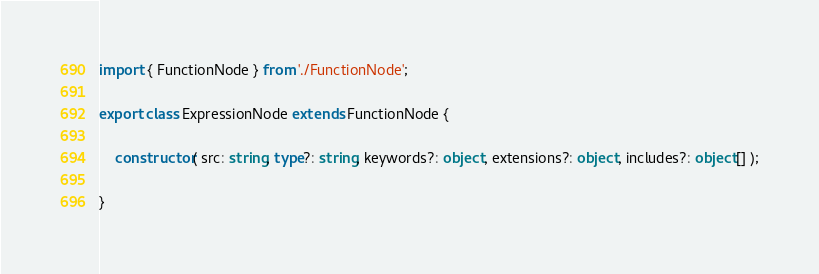Convert code to text. <code><loc_0><loc_0><loc_500><loc_500><_TypeScript_>import { FunctionNode } from './FunctionNode';

export class ExpressionNode extends FunctionNode {

	constructor( src: string, type?: string, keywords?: object, extensions?: object, includes?: object[] );

}
</code> 